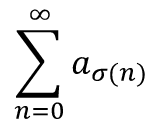Convert formula to latex. <formula><loc_0><loc_0><loc_500><loc_500>\sum _ { n = 0 } ^ { \infty } a _ { \sigma ( n ) }</formula> 